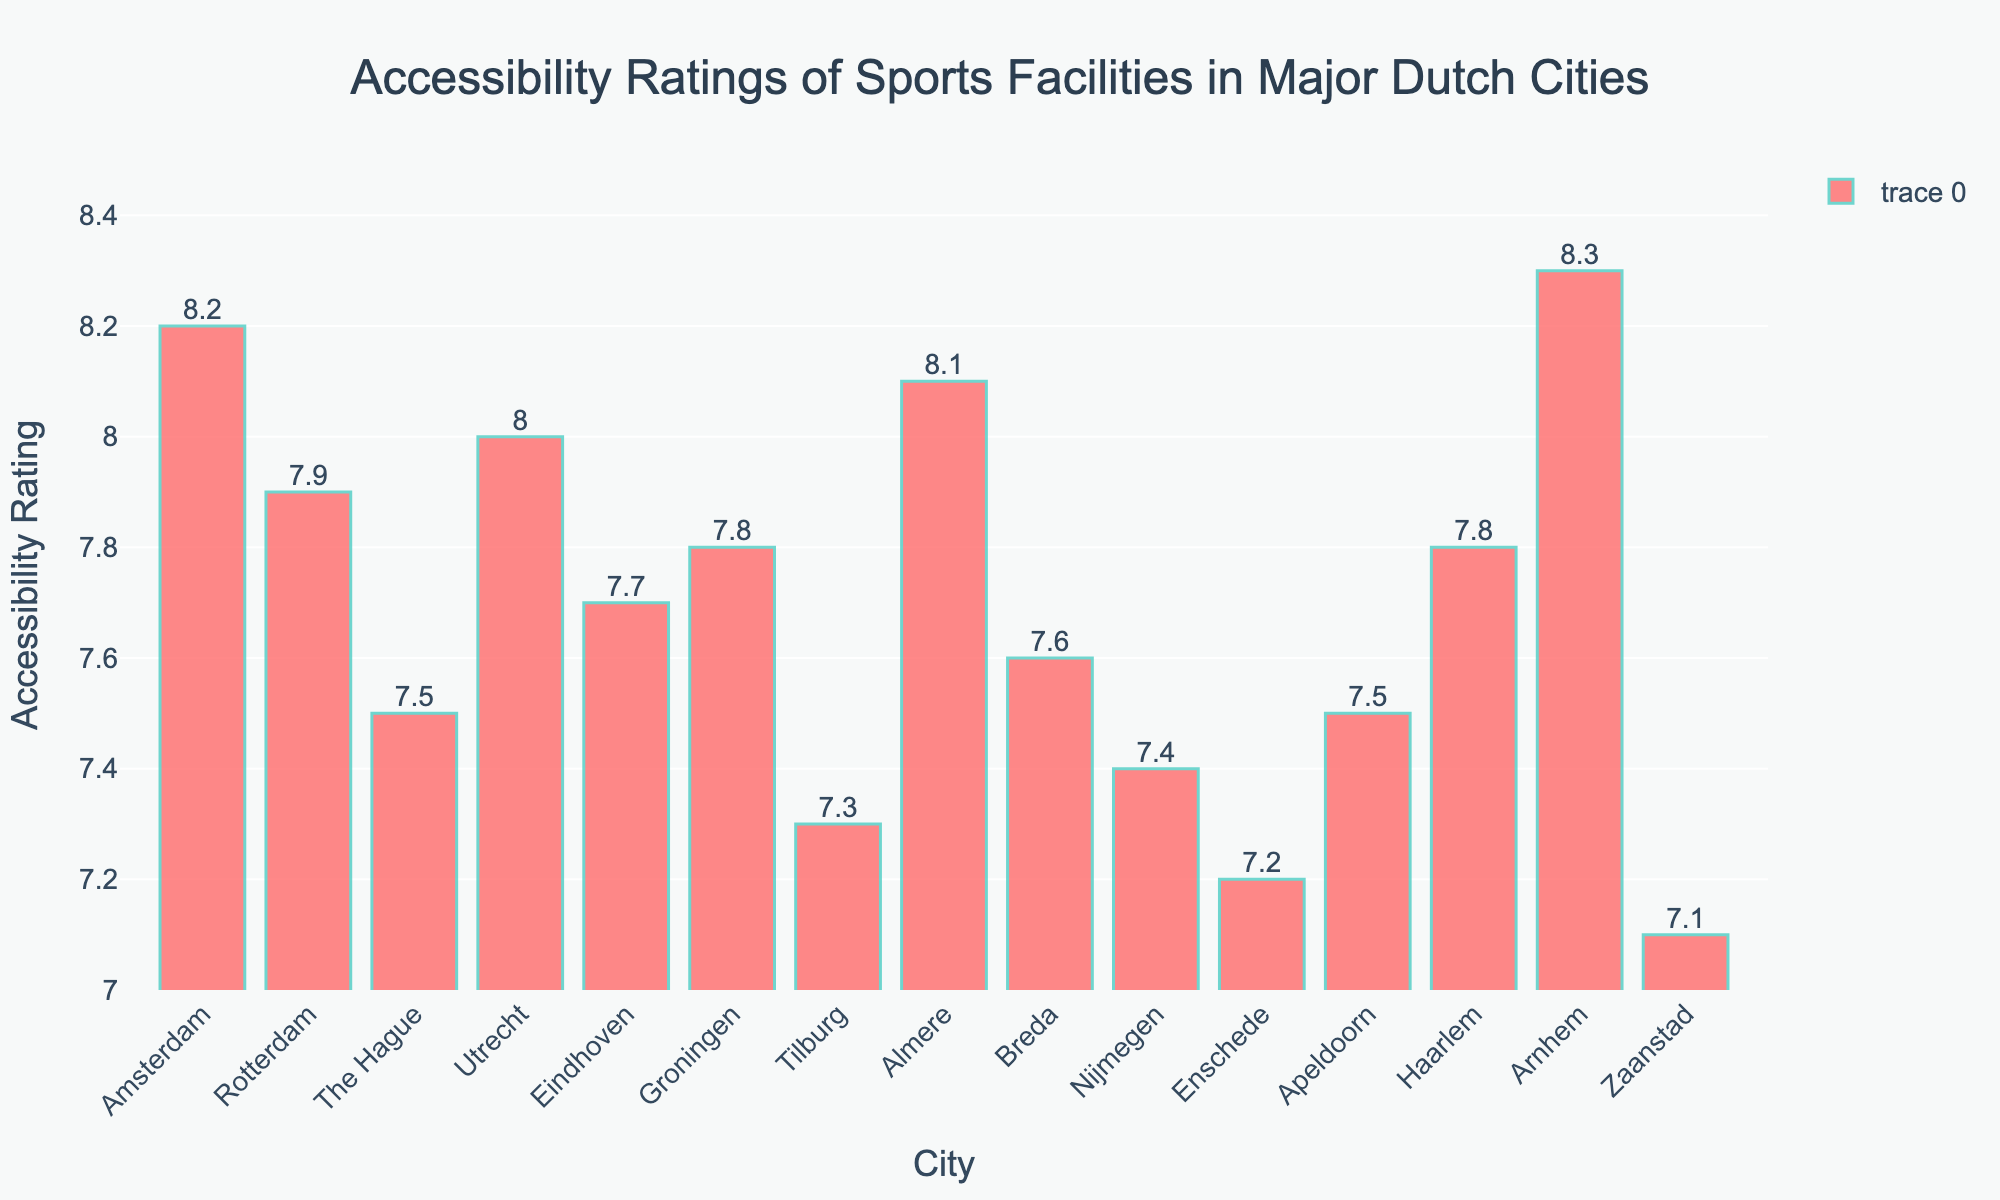Which city has the highest accessibility rating? The tallest bar in the chart represents the city with the highest accessibility rating. By observing the heights of the bars, the tallest bar corresponds to Arnhem.
Answer: Arnhem Which city has the lowest accessibility rating? The shortest bar in the chart represents the city with the lowest accessibility rating. By observing the heights of the bars, the shortest bar corresponds to Zaanstad.
Answer: Zaanstad What is the difference in accessibility rating between Amsterdam and Rotterdam? First, check the heights of the bars for Amsterdam and Rotterdam. Amsterdam has a rating of 8.2, and Rotterdam has a rating of 7.9. Subtract Rotterdam's rating from Amsterdam's rating: 8.2 - 7.9 = 0.3.
Answer: 0.3 What is the average accessibility rating of the three cities with the highest ratings? Identify the three cities with the highest ratings: Arnhem (8.3), Amsterdam (8.2), and Almere (8.1). Calculate the average: (8.3 + 8.2 + 8.1) / 3 = 8.2.
Answer: 8.2 How many cities have an accessibility rating above 8.0? Count the number of bars with heights corresponding to ratings above 8.0. The cities are Amsterdam, Utrecht, Almere, and Arnhem. There are 4 cities.
Answer: 4 Which two cities have the closest accessibility ratings, and what are those ratings? Identify the cities with the smallest difference between their ratings. The closest ratings are Groningen (7.8) and Haarlem (7.8), both with the same rating.
Answer: Groningen and Haarlem, 7.8 What is the median accessibility rating of all the cities? Sort the accessibility ratings in ascending order: 7.1, 7.2, 7.3, 7.4, 7.5, 7.5, 7.6, 7.7, 7.8, 7.8, 7.9, 8.0, 8.1, 8.2, 8.3. The middle value (8th value) is the median: 7.7.
Answer: 7.7 Which city has a rating closest to the average accessibility rating of all cities? Calculate the average accessibility rating: sum of ratings / number of cities = (sum of all ratings) / 15. Sum of ratings is 113.1, so average is 113.1 / 15 = 7.54. The closest rating to 7.54 is 7.5. Compare the closest city ratings: The Hague and Apeldoorn (both 7.5).
Answer: The Hague and Apeldoorn How many cities have accessibility ratings between 7.5 and 8.0 (inclusive)? Count the number of bars corresponding to ratings from 7.5 to 8.0, inclusive of these values: 7.5 (The Hague, Apeldoorn), 7.6 (Breda), 7.7 (Eindhoven), 7.8 (Groningen, Haarlem), 7.9 (Rotterdam). There are 7 cities.
Answer: 7 Compare the accessibility ratings of cities in the range of 7.0 to 7.5. Which city stands out, and why? Identify the city with the lowest rating within this range: Zaanstad (7.1), Enschede (7.2), Tilburg (7.3), Nijmegen (7.4), The Hague and Apeldoorn (7.5). Zaanstad stands out as it has the lowest rating.
Answer: Zaanstad stands out due to having the lowest rating of 7.1 